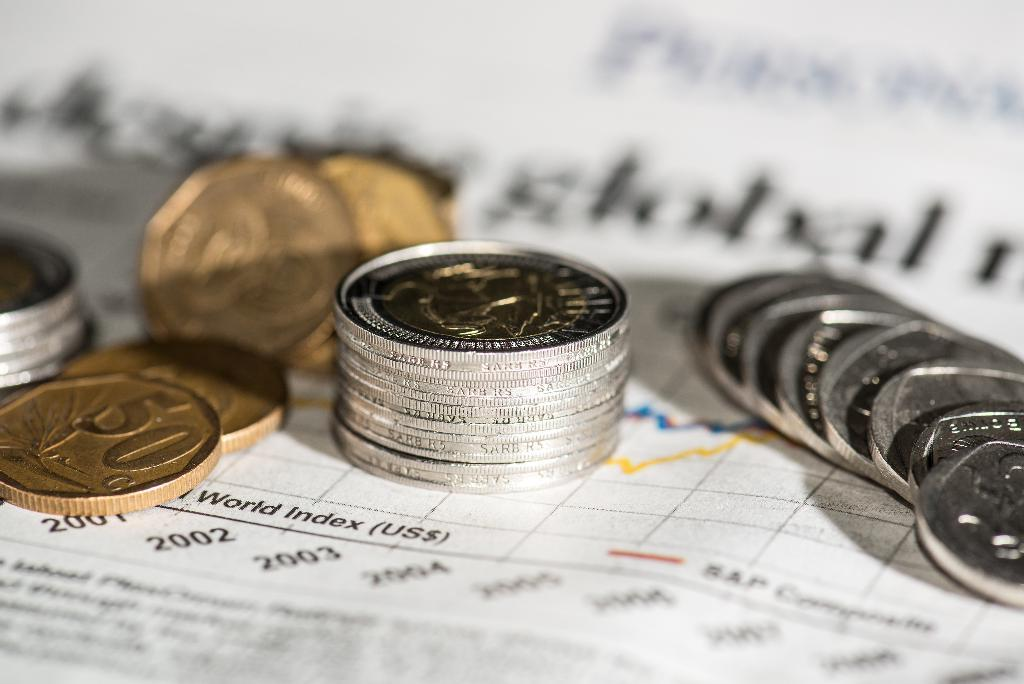<image>
Share a concise interpretation of the image provided. stacks of coins for denominations like 50c on a graph 